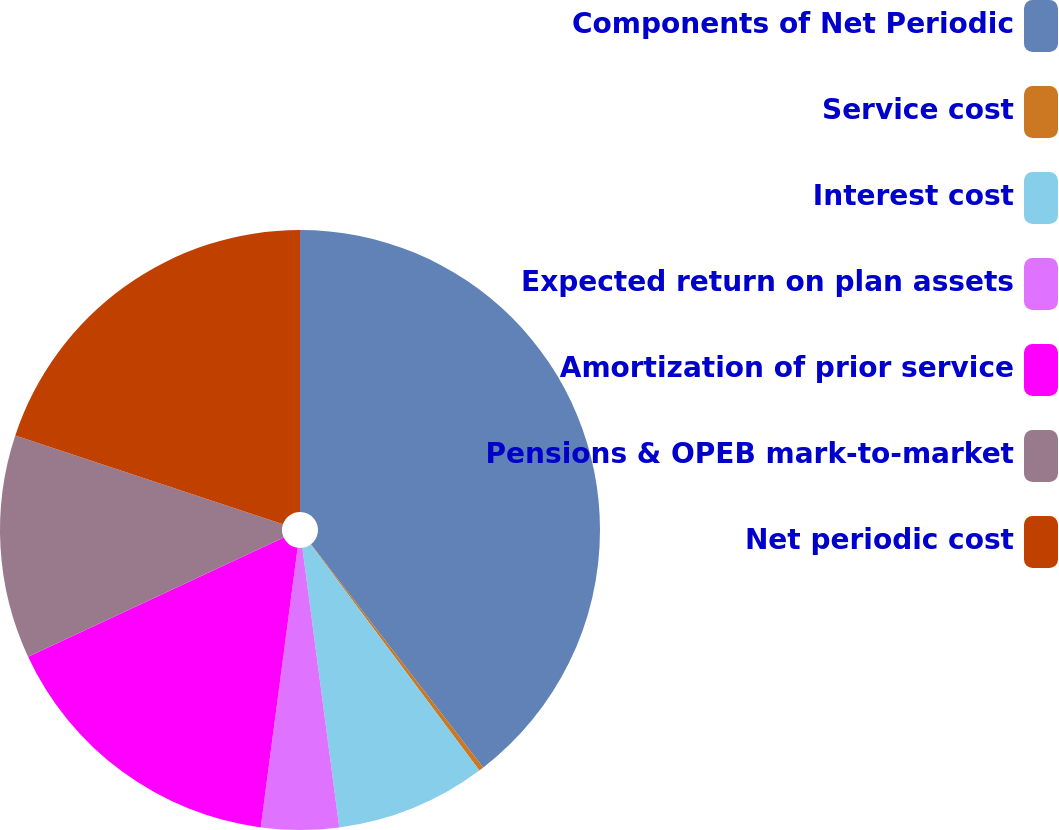Convert chart. <chart><loc_0><loc_0><loc_500><loc_500><pie_chart><fcel>Components of Net Periodic<fcel>Service cost<fcel>Interest cost<fcel>Expected return on plan assets<fcel>Amortization of prior service<fcel>Pensions & OPEB mark-to-market<fcel>Net periodic cost<nl><fcel>39.54%<fcel>0.26%<fcel>8.11%<fcel>4.18%<fcel>15.97%<fcel>12.04%<fcel>19.9%<nl></chart> 